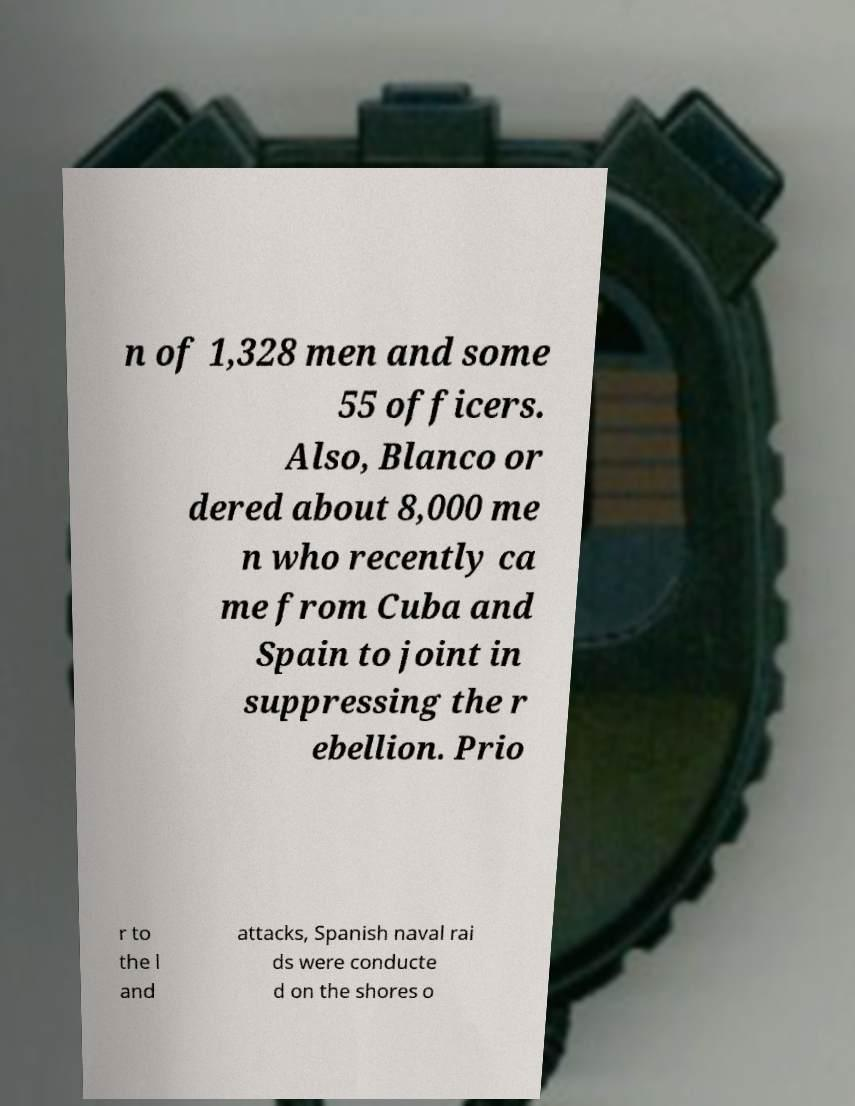What messages or text are displayed in this image? I need them in a readable, typed format. n of 1,328 men and some 55 officers. Also, Blanco or dered about 8,000 me n who recently ca me from Cuba and Spain to joint in suppressing the r ebellion. Prio r to the l and attacks, Spanish naval rai ds were conducte d on the shores o 